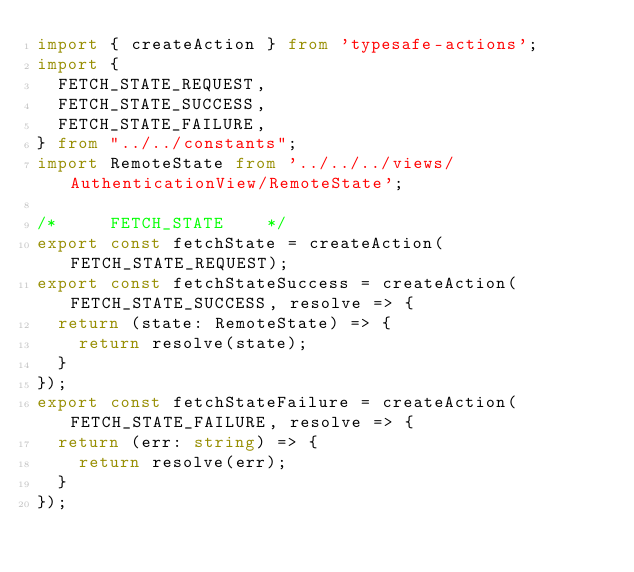<code> <loc_0><loc_0><loc_500><loc_500><_TypeScript_>import { createAction } from 'typesafe-actions';
import {
  FETCH_STATE_REQUEST,
  FETCH_STATE_SUCCESS,
  FETCH_STATE_FAILURE,
} from "../../constants";
import RemoteState from '../../../views/AuthenticationView/RemoteState';

/*     FETCH_STATE    */
export const fetchState = createAction(FETCH_STATE_REQUEST);
export const fetchStateSuccess = createAction(FETCH_STATE_SUCCESS, resolve => {
  return (state: RemoteState) => {
    return resolve(state);
  }
});
export const fetchStateFailure = createAction(FETCH_STATE_FAILURE, resolve => {
  return (err: string) => {
    return resolve(err);
  }
});</code> 